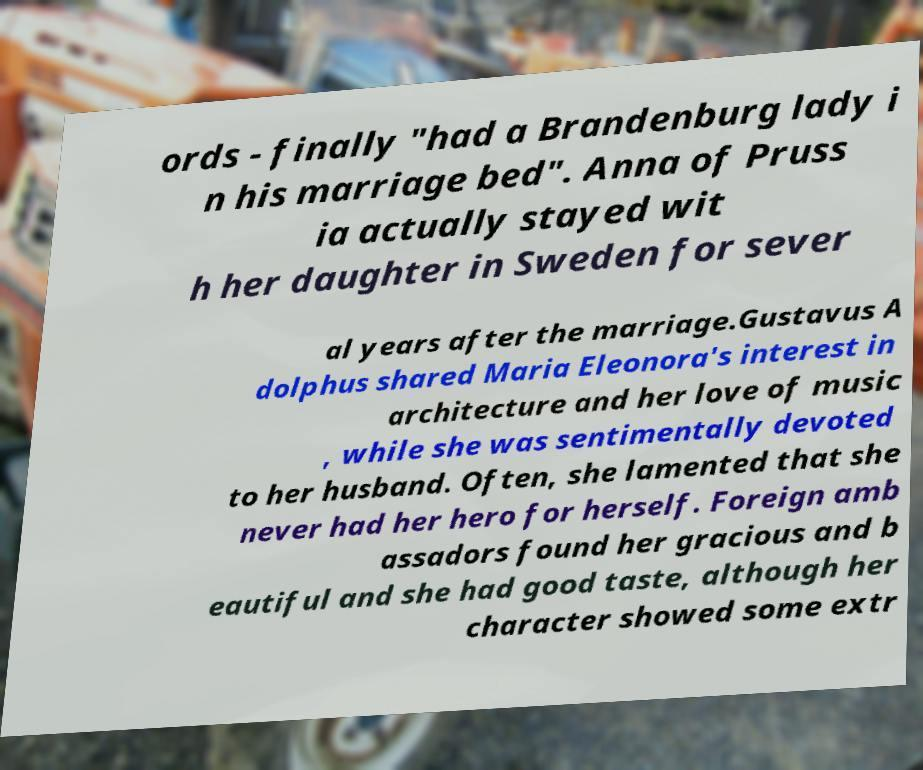For documentation purposes, I need the text within this image transcribed. Could you provide that? ords - finally "had a Brandenburg lady i n his marriage bed". Anna of Pruss ia actually stayed wit h her daughter in Sweden for sever al years after the marriage.Gustavus A dolphus shared Maria Eleonora's interest in architecture and her love of music , while she was sentimentally devoted to her husband. Often, she lamented that she never had her hero for herself. Foreign amb assadors found her gracious and b eautiful and she had good taste, although her character showed some extr 